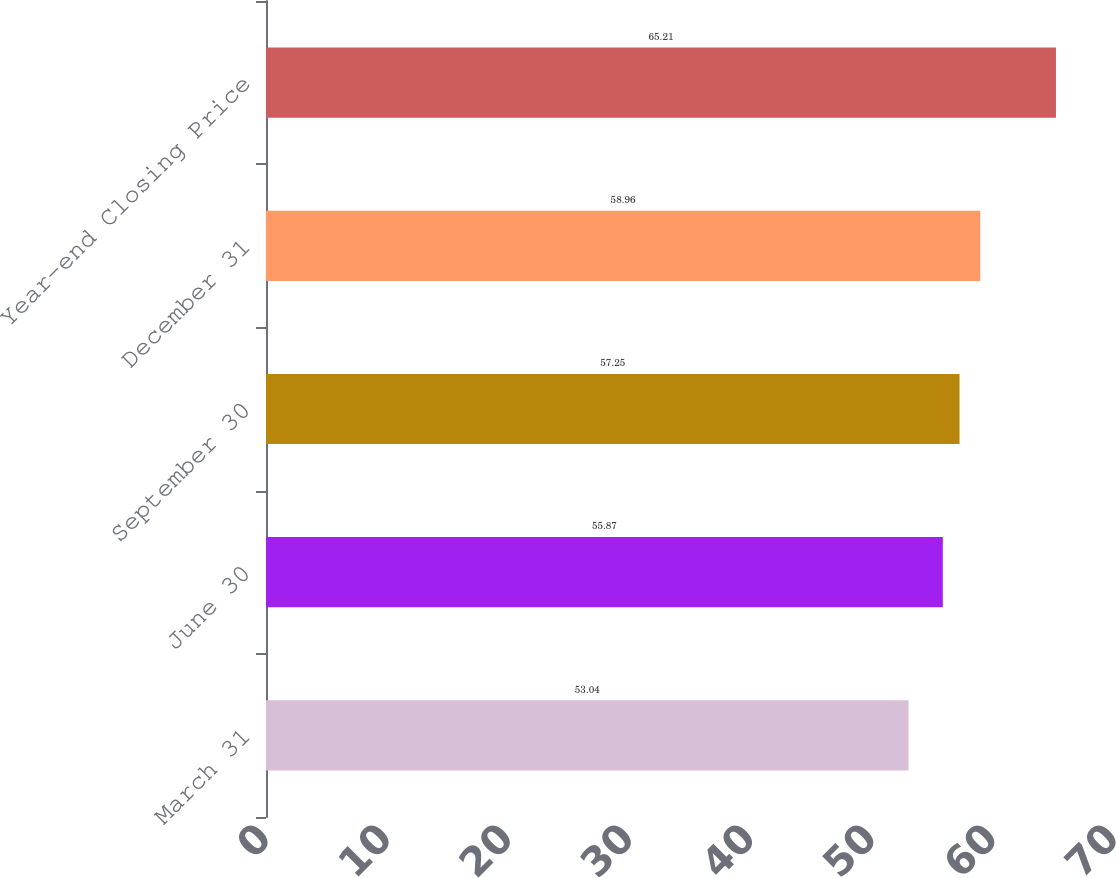Convert chart. <chart><loc_0><loc_0><loc_500><loc_500><bar_chart><fcel>March 31<fcel>June 30<fcel>September 30<fcel>December 31<fcel>Year-end Closing Price<nl><fcel>53.04<fcel>55.87<fcel>57.25<fcel>58.96<fcel>65.21<nl></chart> 